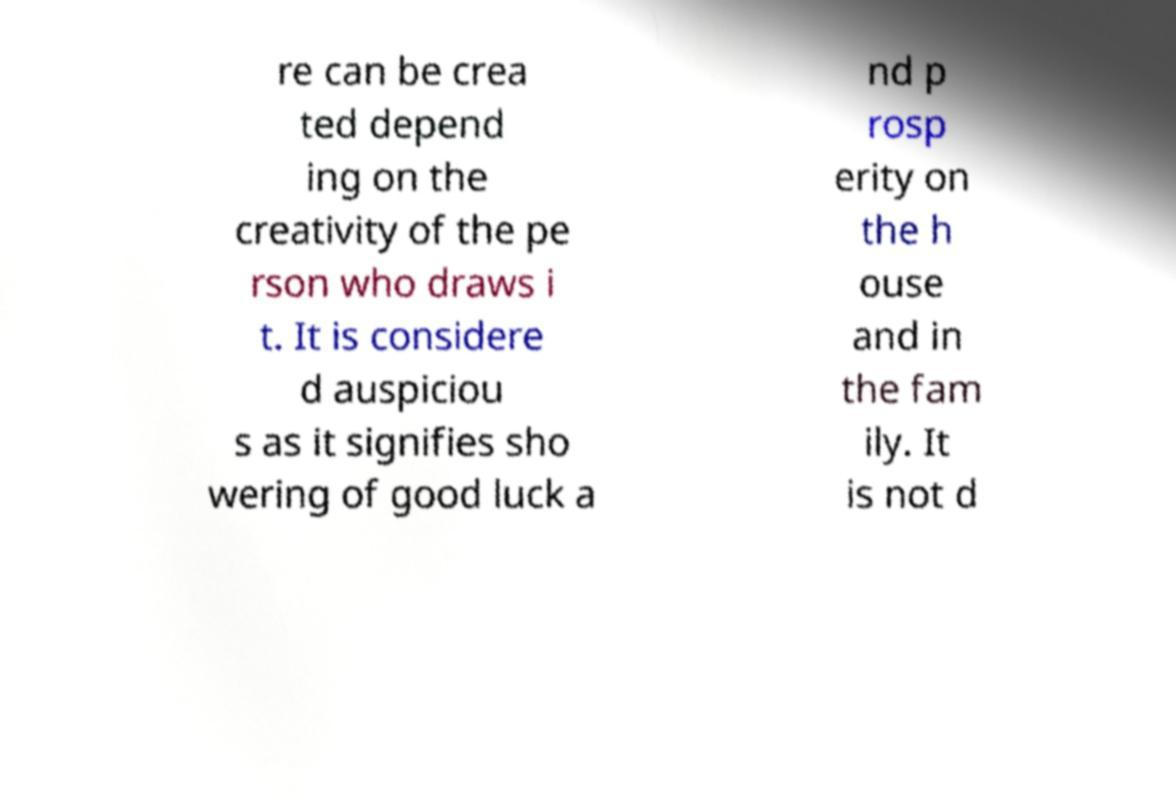What messages or text are displayed in this image? I need them in a readable, typed format. re can be crea ted depend ing on the creativity of the pe rson who draws i t. It is considere d auspiciou s as it signifies sho wering of good luck a nd p rosp erity on the h ouse and in the fam ily. It is not d 